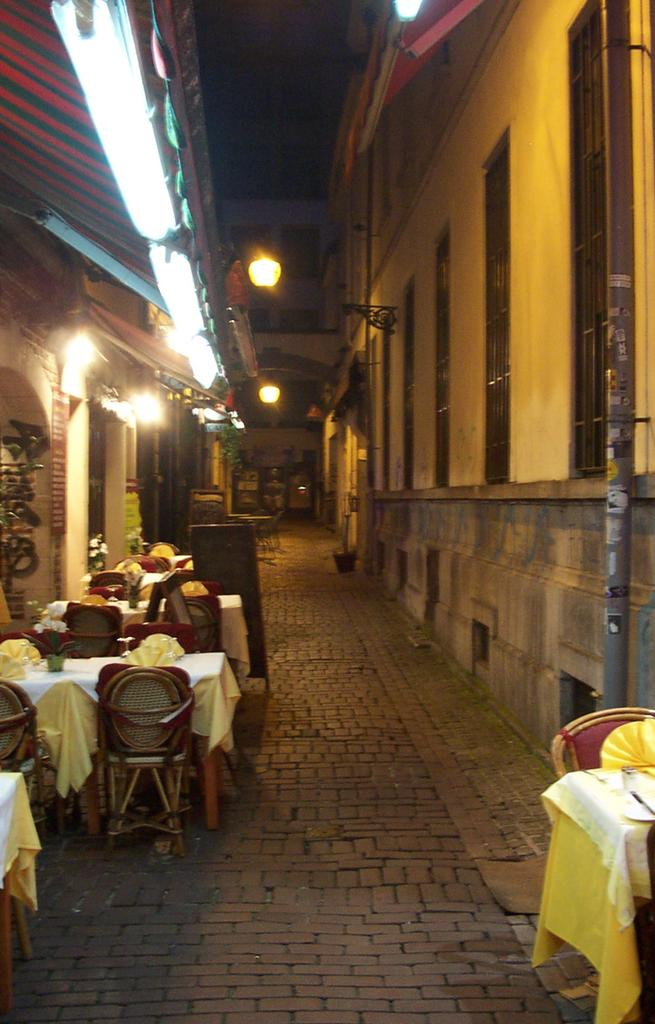What type of furniture is present around the tables in the image? There are chairs around the tables in the image. What can be found on top of the tables? There are objects on the tables. What is the prominent feature in the foreground area of the image? There is a pole in the foreground area of the image. What type of structures are depicted in the image? The image appears to depict architectures. What part of the buildings can be seen in the image? Roofs are visible in the image. What is visible in the background of the image? The sky is visible in the background of the image. What type of soap is being used to clean the muscle in the image? There is no soap or muscle present in the image; it depicts architectures and furniture. 